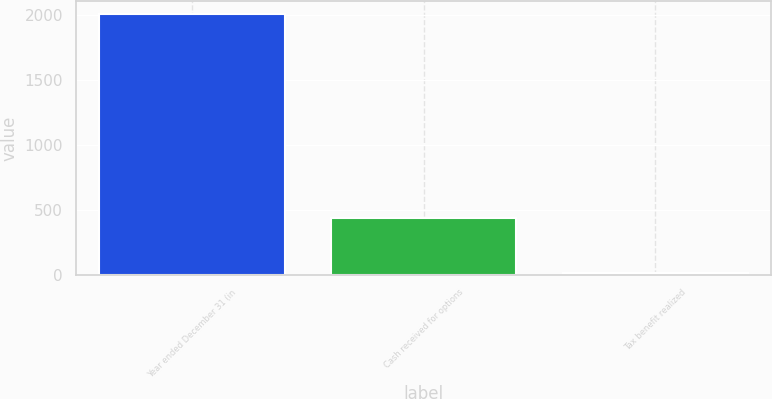Convert chart to OTSL. <chart><loc_0><loc_0><loc_500><loc_500><bar_chart><fcel>Year ended December 31 (in<fcel>Cash received for options<fcel>Tax benefit realized<nl><fcel>2009<fcel>437<fcel>11<nl></chart> 